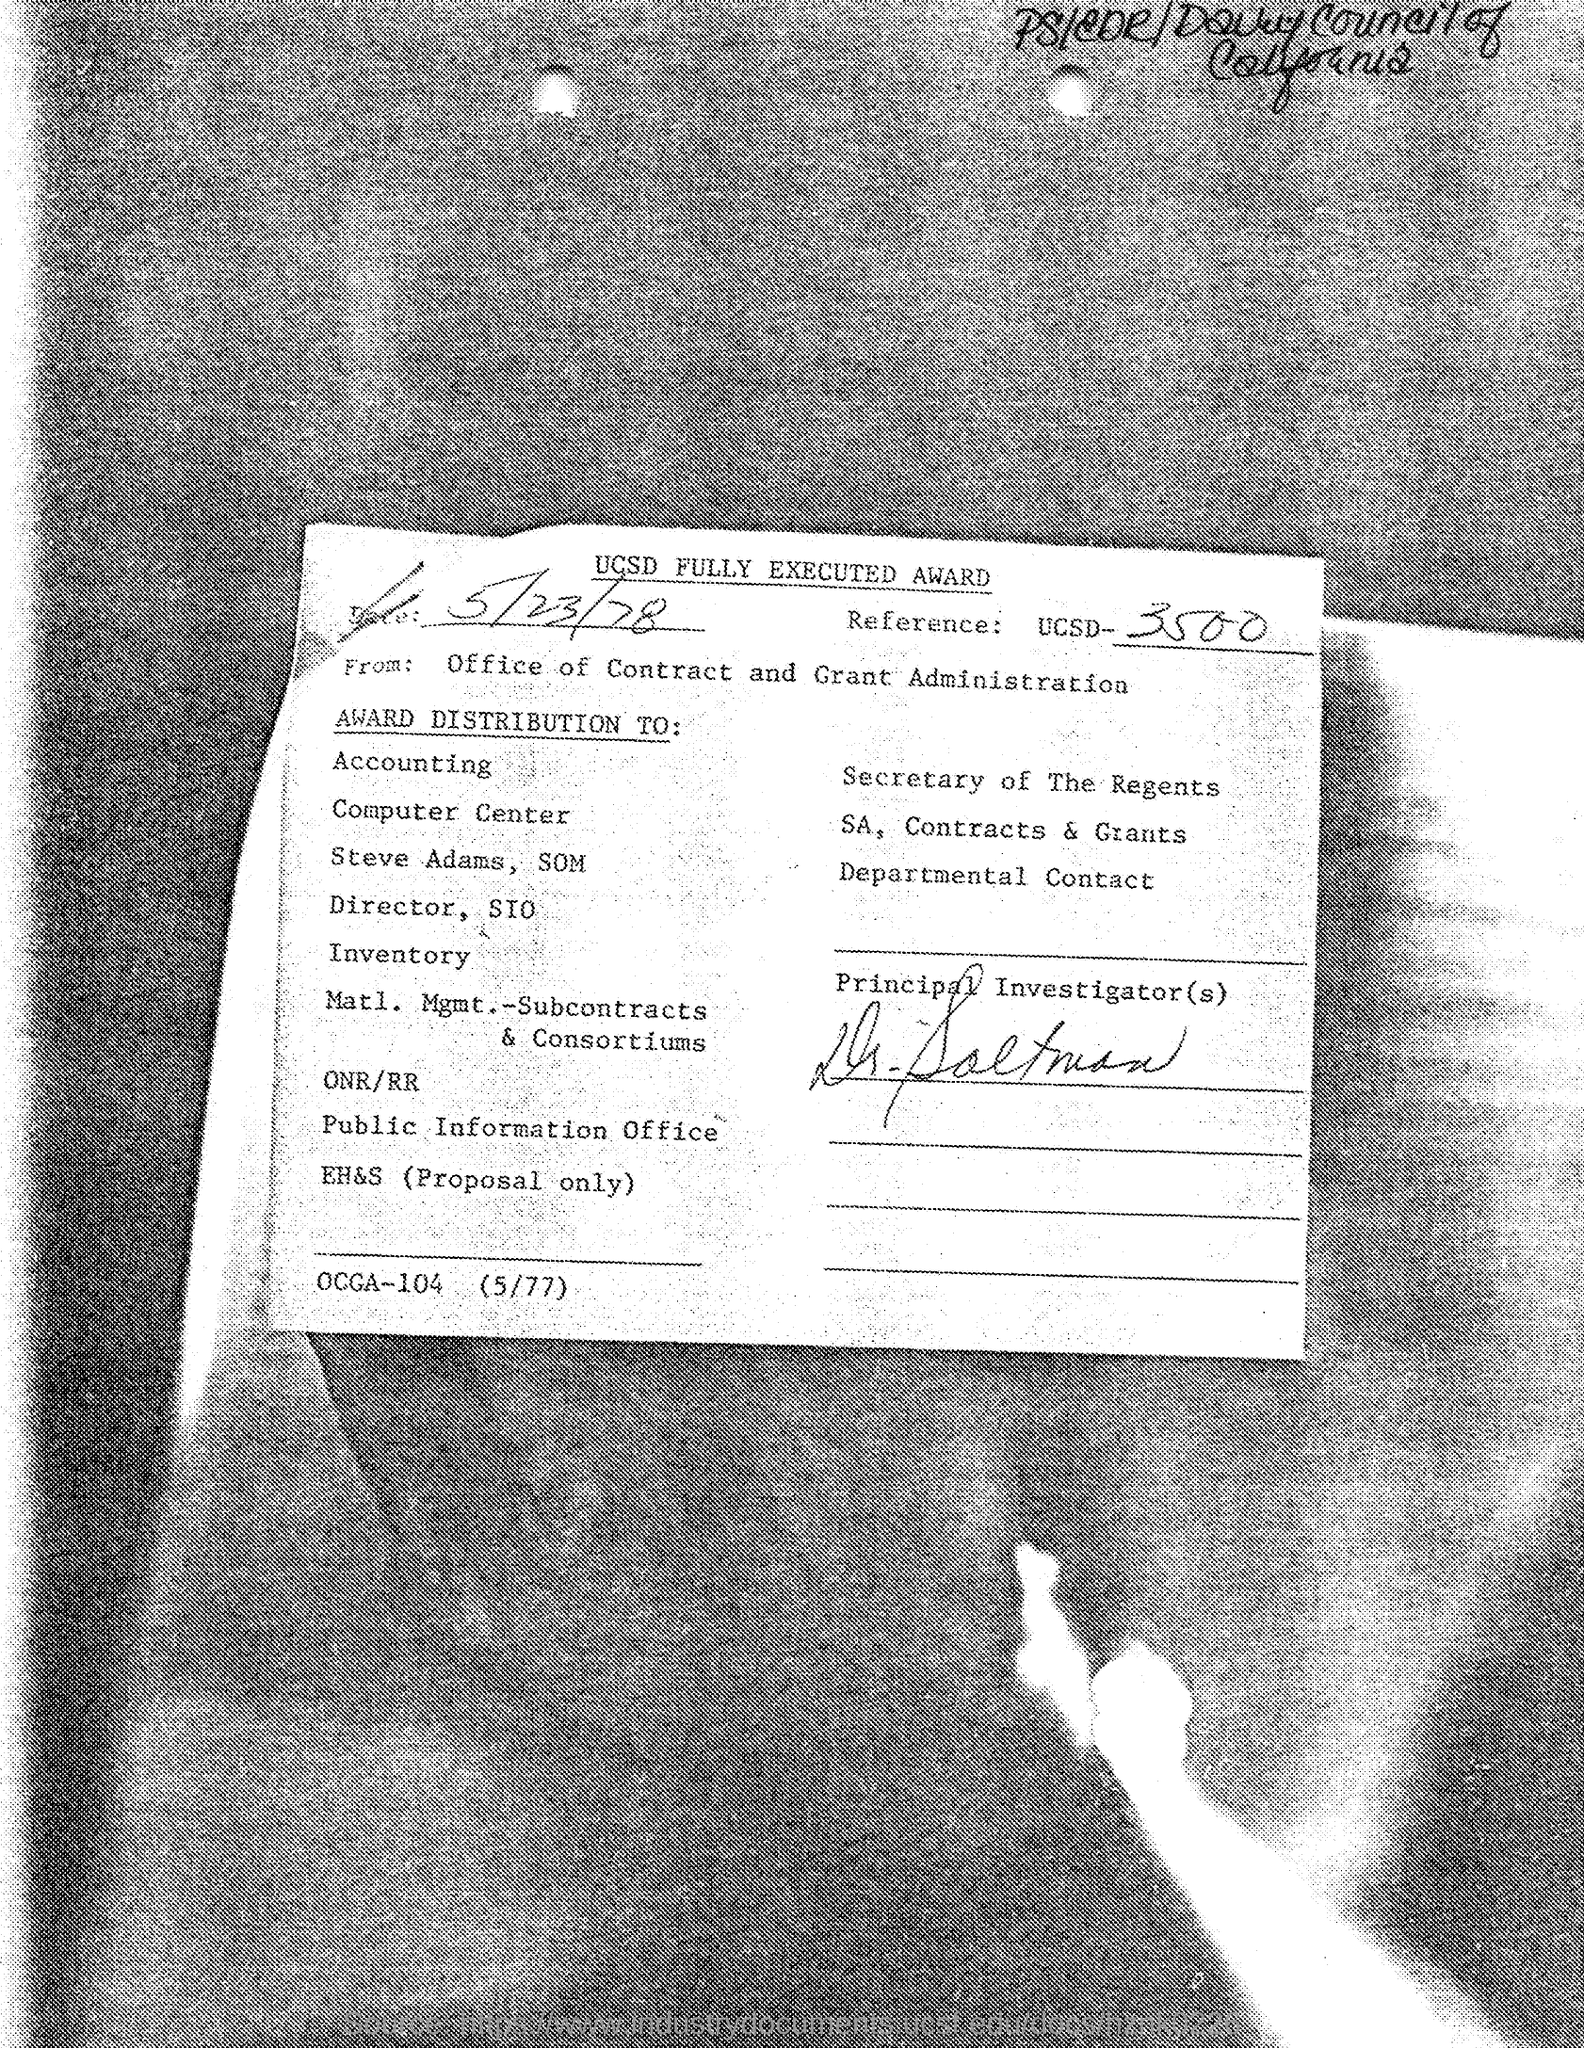Give some essential details in this illustration. What is the title of the document?" the witness inquired. "UCSD FULLY EXECUTED AWARD," the document was declared. May 23rd, 1978, is the date in question. 